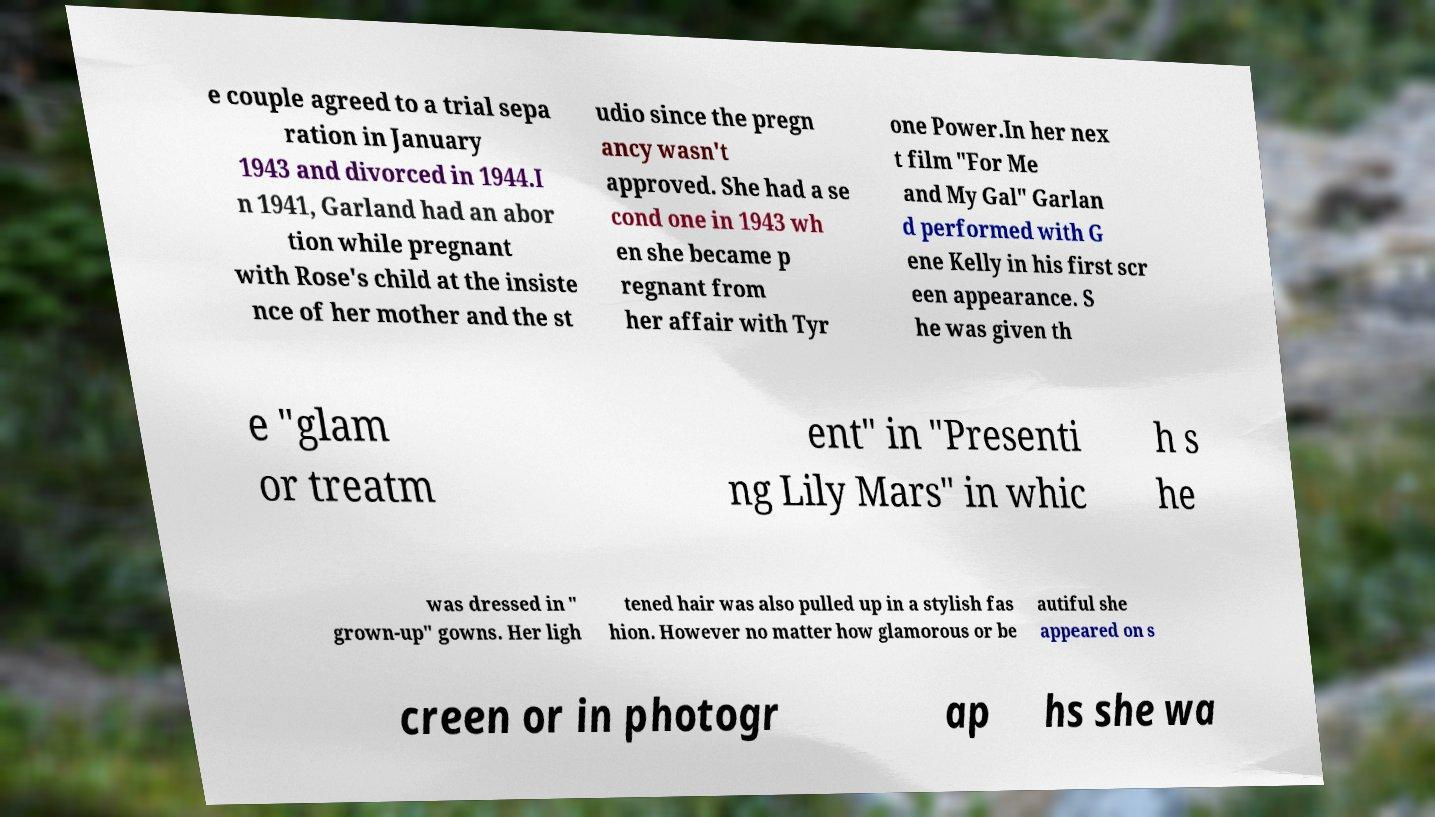There's text embedded in this image that I need extracted. Can you transcribe it verbatim? e couple agreed to a trial sepa ration in January 1943 and divorced in 1944.I n 1941, Garland had an abor tion while pregnant with Rose's child at the insiste nce of her mother and the st udio since the pregn ancy wasn't approved. She had a se cond one in 1943 wh en she became p regnant from her affair with Tyr one Power.In her nex t film "For Me and My Gal" Garlan d performed with G ene Kelly in his first scr een appearance. S he was given th e "glam or treatm ent" in "Presenti ng Lily Mars" in whic h s he was dressed in " grown-up" gowns. Her ligh tened hair was also pulled up in a stylish fas hion. However no matter how glamorous or be autiful she appeared on s creen or in photogr ap hs she wa 